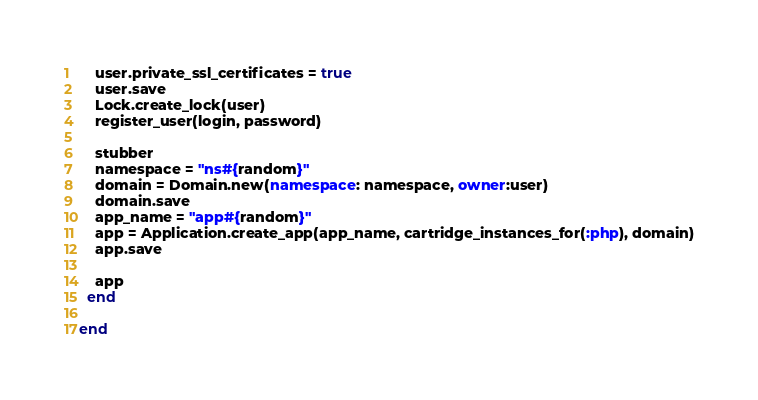<code> <loc_0><loc_0><loc_500><loc_500><_Ruby_>    user.private_ssl_certificates = true
    user.save
    Lock.create_lock(user)
    register_user(login, password)

    stubber
    namespace = "ns#{random}"
    domain = Domain.new(namespace: namespace, owner:user)
    domain.save
    app_name = "app#{random}"
    app = Application.create_app(app_name, cartridge_instances_for(:php), domain)
    app.save

    app
  end

end
</code> 